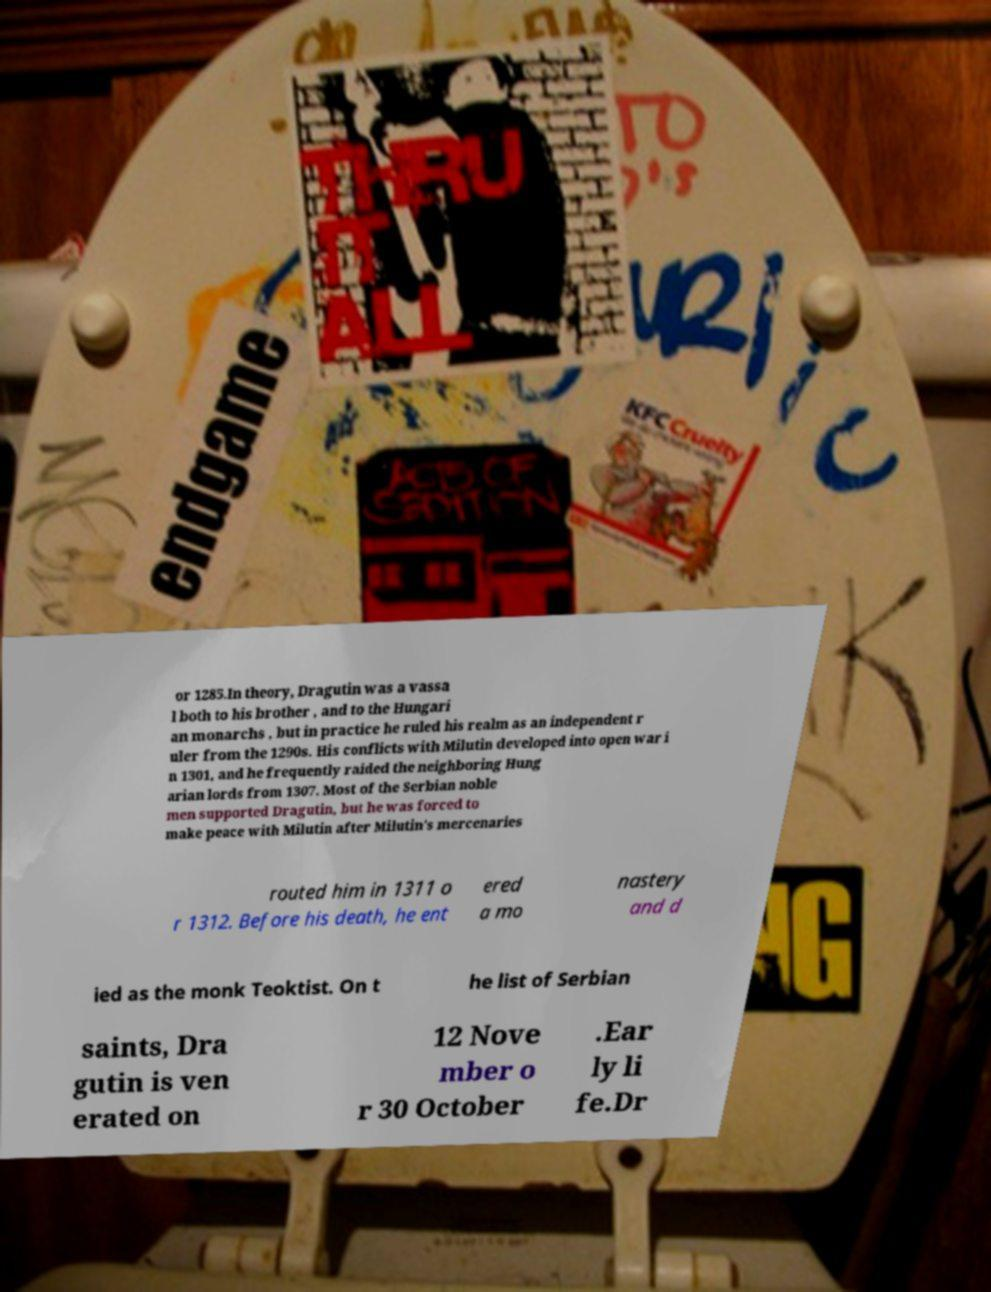For documentation purposes, I need the text within this image transcribed. Could you provide that? or 1285.In theory, Dragutin was a vassa l both to his brother , and to the Hungari an monarchs , but in practice he ruled his realm as an independent r uler from the 1290s. His conflicts with Milutin developed into open war i n 1301, and he frequently raided the neighboring Hung arian lords from 1307. Most of the Serbian noble men supported Dragutin, but he was forced to make peace with Milutin after Milutin's mercenaries routed him in 1311 o r 1312. Before his death, he ent ered a mo nastery and d ied as the monk Teoktist. On t he list of Serbian saints, Dra gutin is ven erated on 12 Nove mber o r 30 October .Ear ly li fe.Dr 